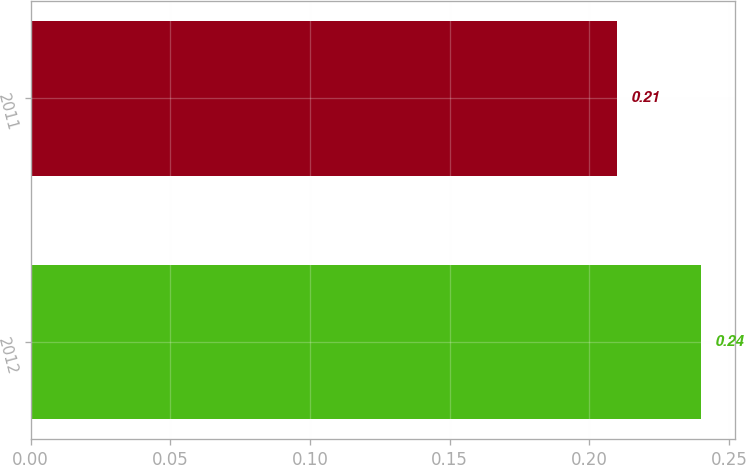<chart> <loc_0><loc_0><loc_500><loc_500><bar_chart><fcel>2012<fcel>2011<nl><fcel>0.24<fcel>0.21<nl></chart> 